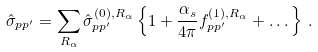Convert formula to latex. <formula><loc_0><loc_0><loc_500><loc_500>\hat { \sigma } _ { p p ^ { \prime } } = \sum _ { R _ { \alpha } } \hat { \sigma } ^ { ( 0 ) , R _ { \alpha } } _ { p p ^ { \prime } } \left \{ 1 + \frac { \alpha _ { s } } { 4 \pi } f ^ { ( 1 ) , R _ { \alpha } } _ { p p ^ { \prime } } + \dots \right \} \, .</formula> 